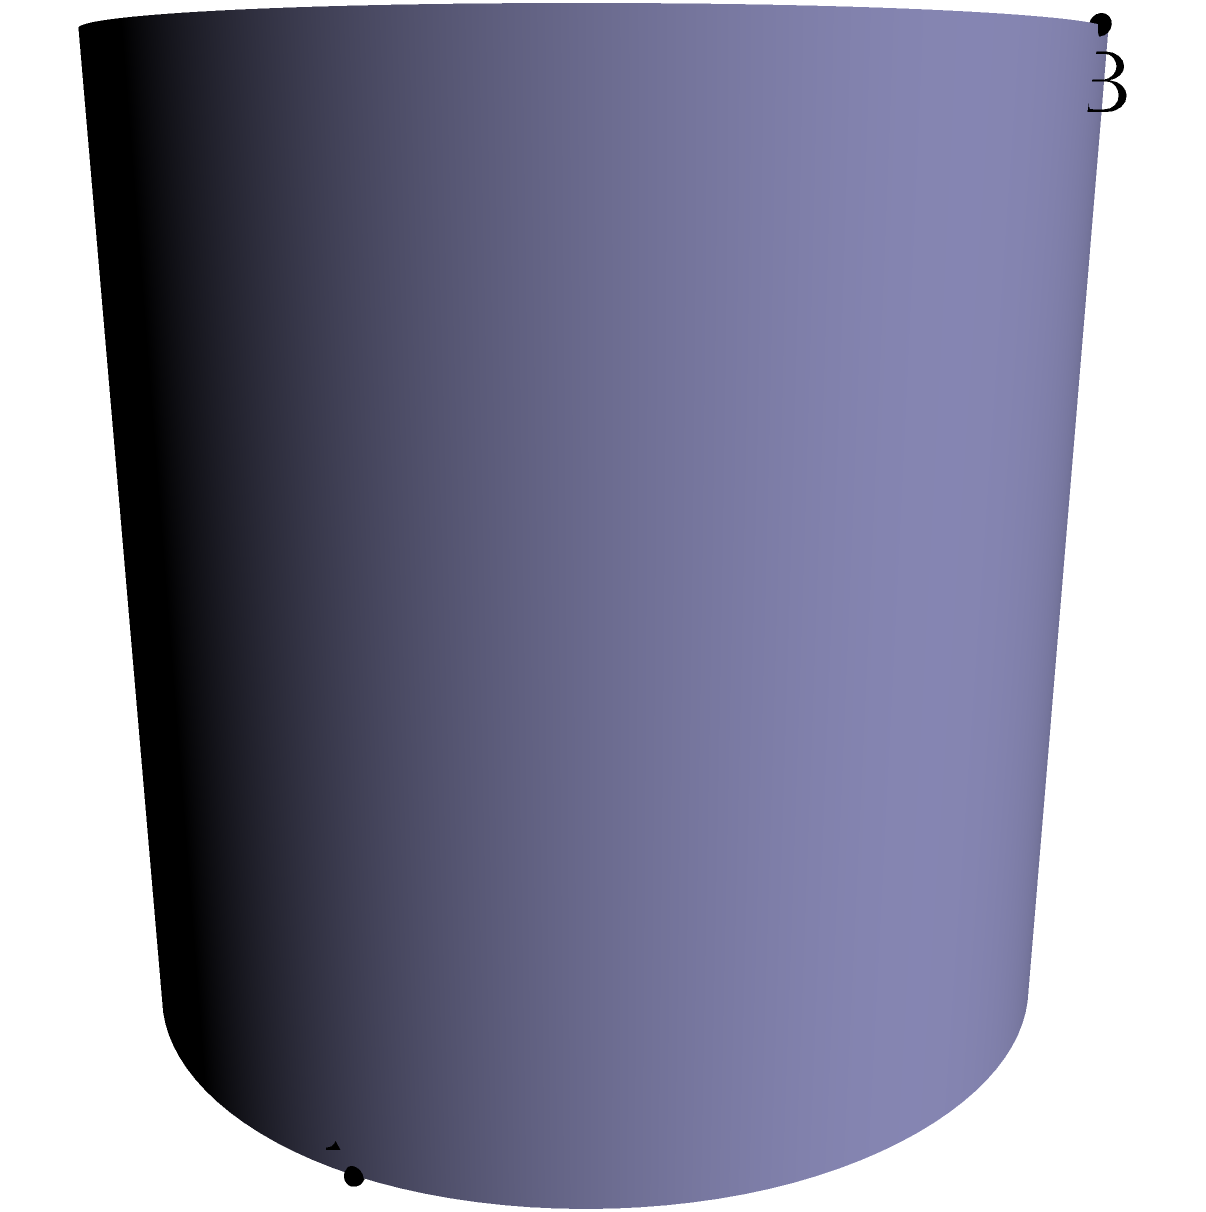On a cylindrical surface with radius 2, what is the shape of the shortest path (geodesic) between points A(2,0,0) and B(0,2,2)? How does this compare to the straight line between these points? To understand the shortest path on a cylindrical surface:

1. Visualize the cylinder: The surface is a cylinder with radius 2, extending along the z-axis.

2. Straight line vs. geodesic:
   - The red line represents the straight line between A and B in 3D space.
   - The green dashed line represents the geodesic (shortest path) on the cylinder's surface.

3. Nature of the geodesic:
   - On a cylinder, the geodesic is a helix.
   - It spirals around the cylinder, connecting A and B along the surface.

4. Mathematical representation:
   - The helix can be parameterized as $$(2\cos(t), 2\sin(t), t)$$ for $0 \leq t \leq 2$.

5. Comparison:
   - The straight line (red) passes through the cylinder.
   - The geodesic (green) follows the surface, resulting in a longer but "shortest possible" path on the surface.

6. Implications for travel:
   - If constrained to the surface, one must follow the helical path.
   - This demonstrates how non-Euclidean geometry affects shortest paths in curved spaces.
Answer: Helix; longer than straight line 